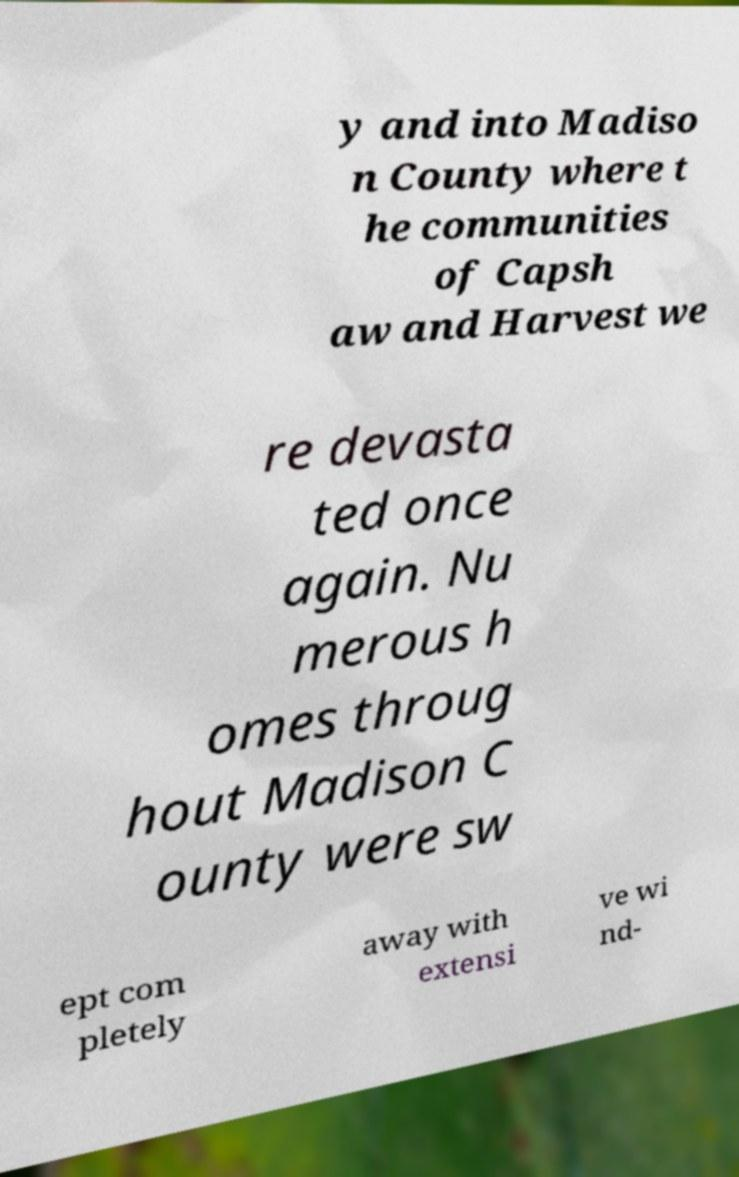For documentation purposes, I need the text within this image transcribed. Could you provide that? y and into Madiso n County where t he communities of Capsh aw and Harvest we re devasta ted once again. Nu merous h omes throug hout Madison C ounty were sw ept com pletely away with extensi ve wi nd- 